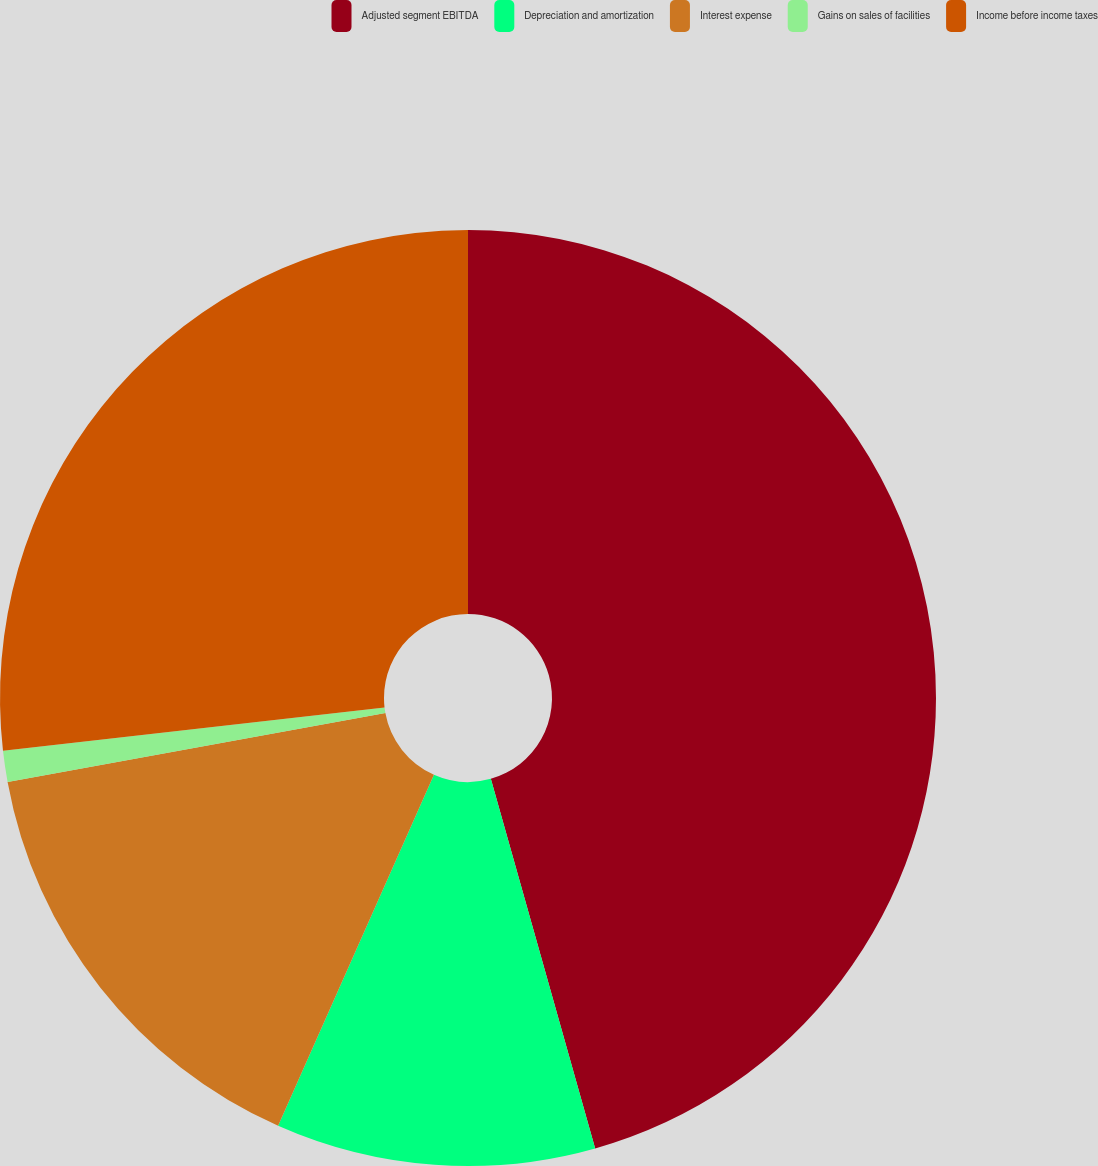Convert chart to OTSL. <chart><loc_0><loc_0><loc_500><loc_500><pie_chart><fcel>Adjusted segment EBITDA<fcel>Depreciation and amortization<fcel>Interest expense<fcel>Gains on sales of facilities<fcel>Income before income taxes<nl><fcel>45.62%<fcel>11.03%<fcel>15.48%<fcel>1.07%<fcel>26.8%<nl></chart> 